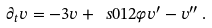Convert formula to latex. <formula><loc_0><loc_0><loc_500><loc_500>\partial _ { t } v = - 3 v + \ s 0 1 2 \varphi v ^ { \prime } - v ^ { \prime \prime } \, .</formula> 